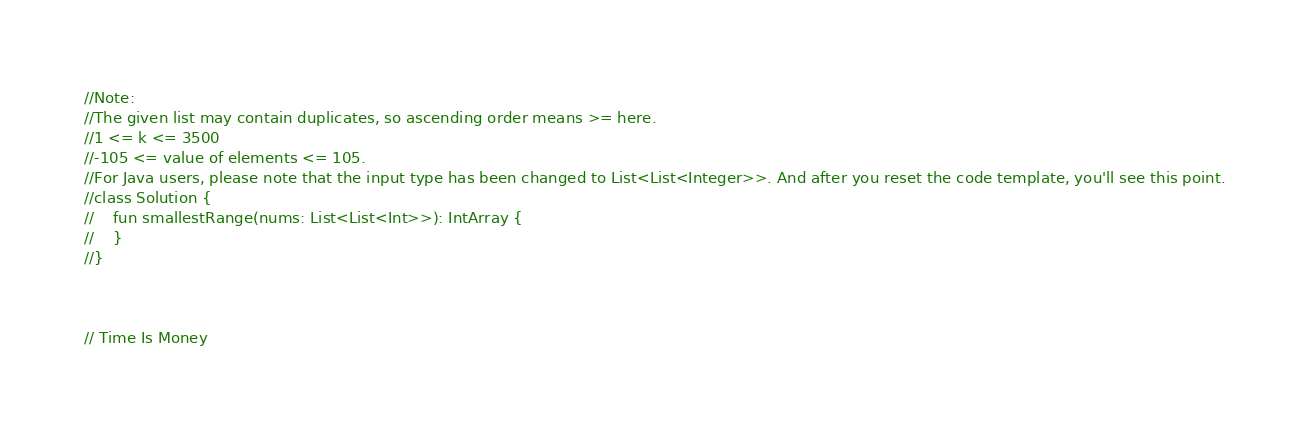<code> <loc_0><loc_0><loc_500><loc_500><_Kotlin_>//Note:
//The given list may contain duplicates, so ascending order means >= here.
//1 <= k <= 3500
//-105 <= value of elements <= 105.
//For Java users, please note that the input type has been changed to List<List<Integer>>. And after you reset the code template, you'll see this point.
//class Solution {
//    fun smallestRange(nums: List<List<Int>>): IntArray {
//    }
//}



// Time Is Money</code> 